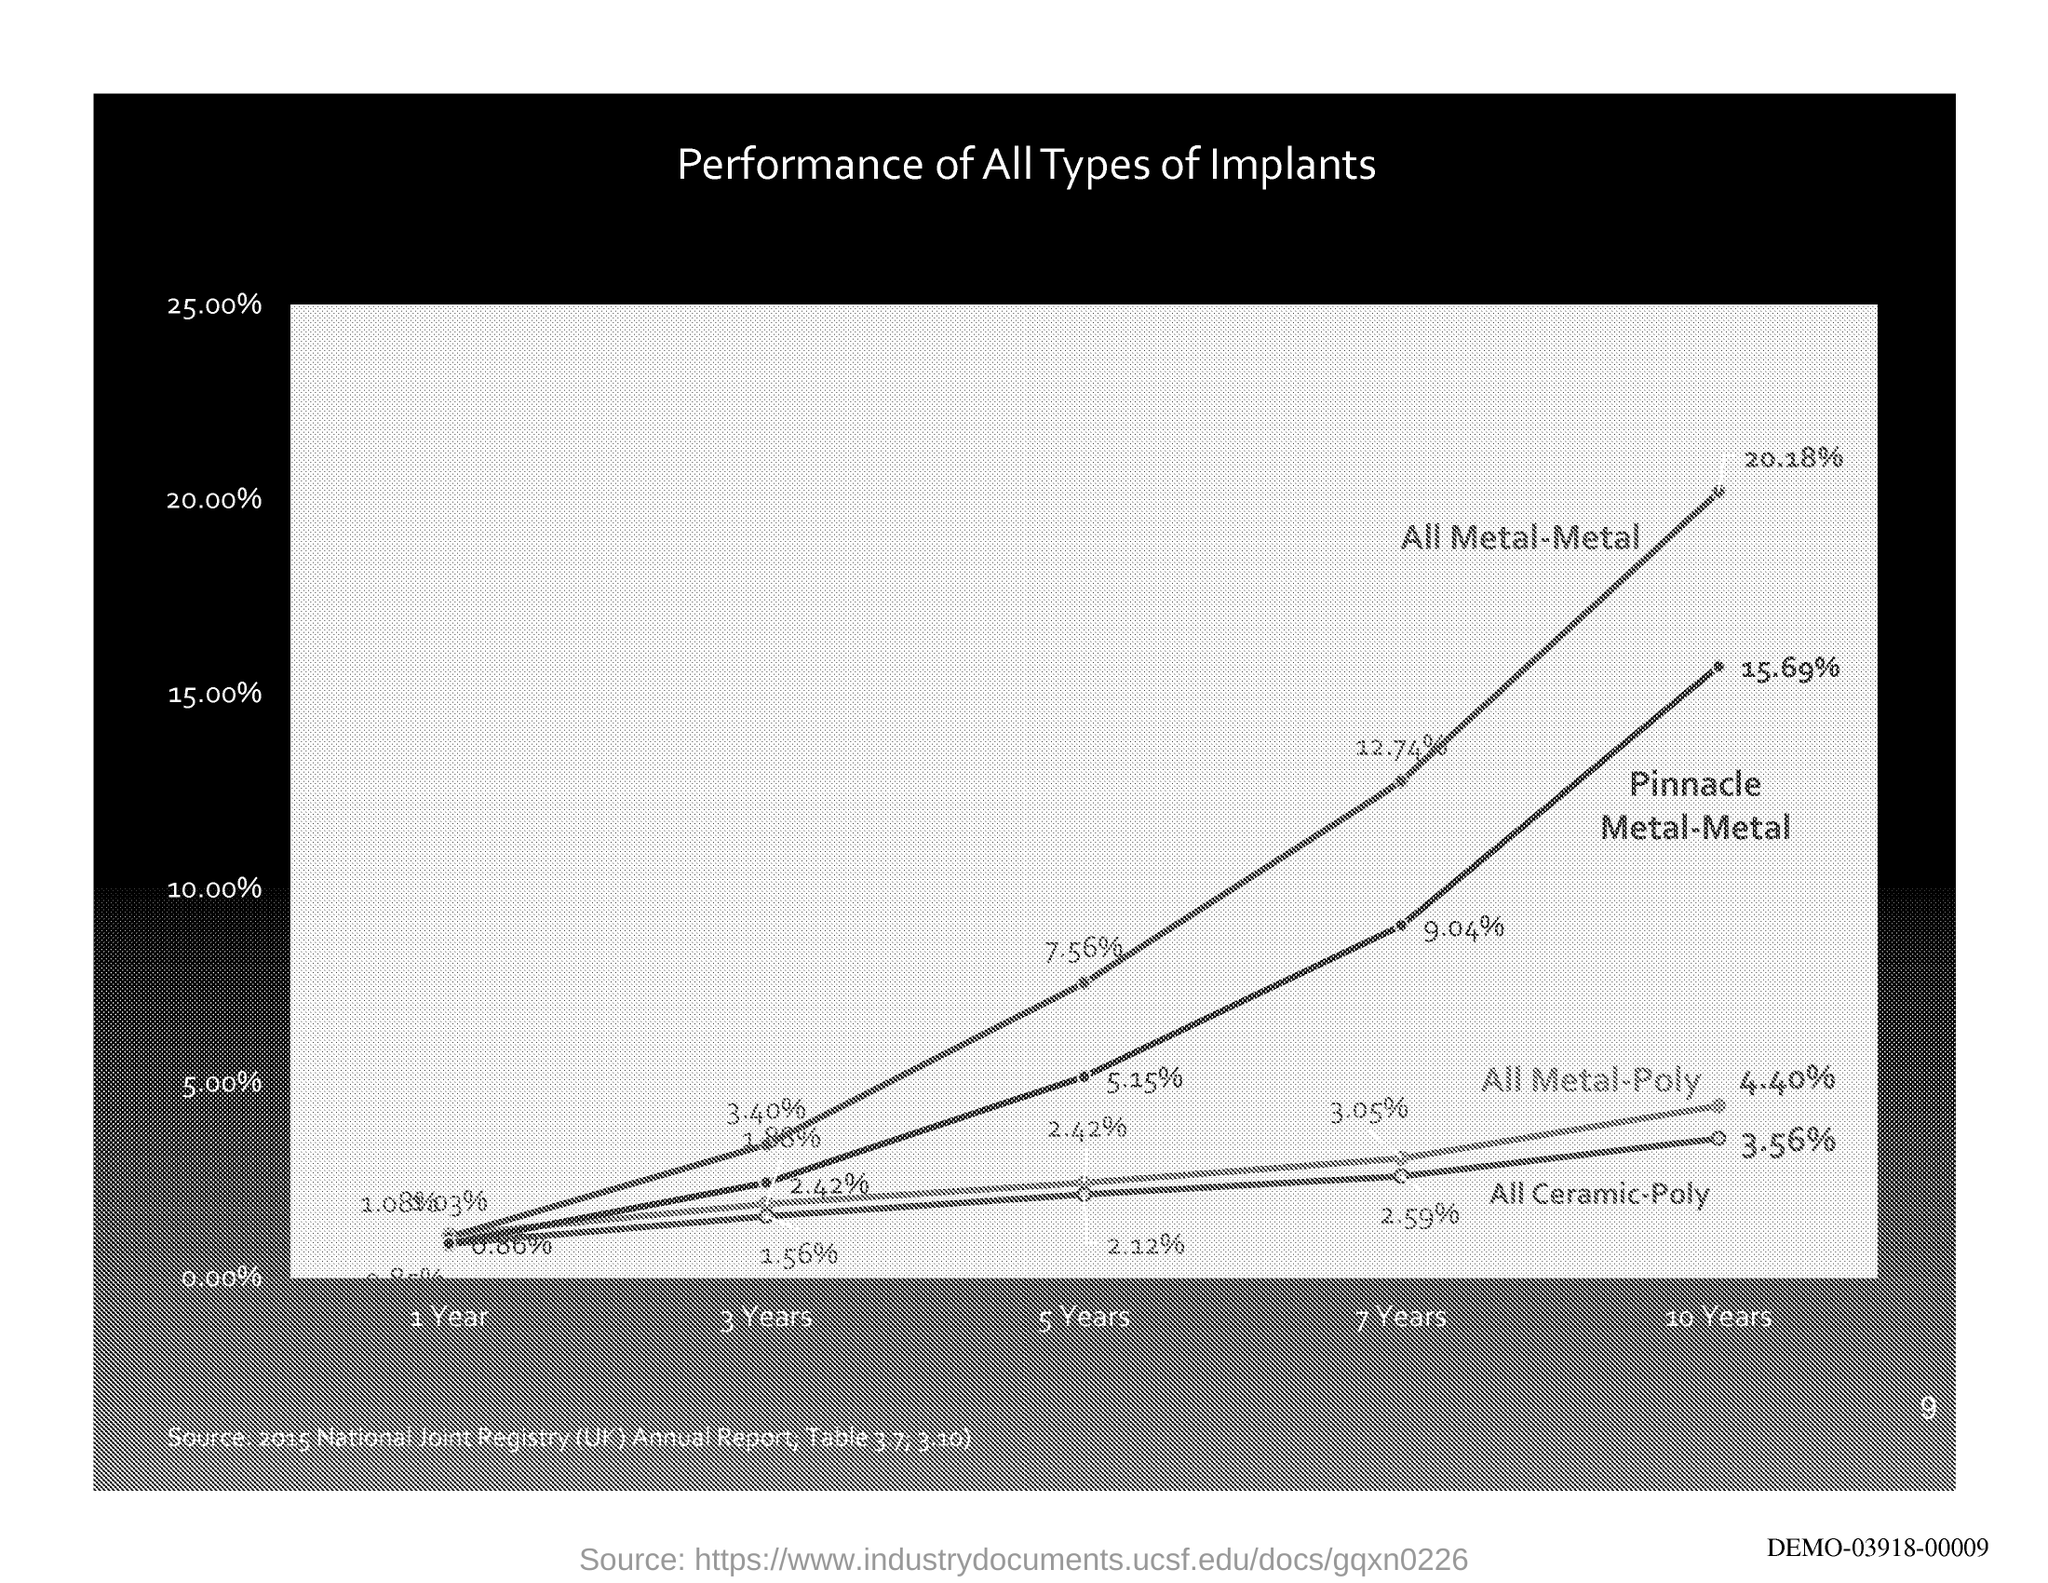Identify some key points in this picture. The title of the graph depicting the performance of all types of implants is [insert title]. 